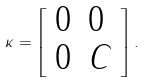Convert formula to latex. <formula><loc_0><loc_0><loc_500><loc_500>\kappa = \left [ \begin{array} { l l } 0 & 0 \\ 0 & C \end{array} \right ] .</formula> 